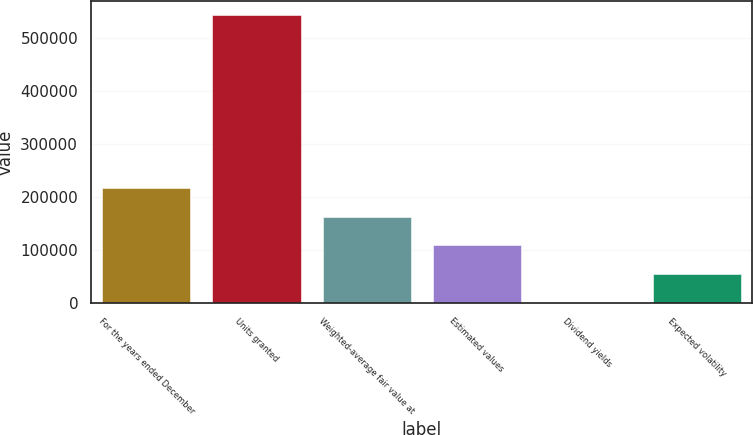<chart> <loc_0><loc_0><loc_500><loc_500><bar_chart><fcel>For the years ended December<fcel>Units granted<fcel>Weighted-average fair value at<fcel>Estimated values<fcel>Dividend yields<fcel>Expected volatility<nl><fcel>217440<fcel>543596<fcel>163081<fcel>108721<fcel>2.7<fcel>54362<nl></chart> 